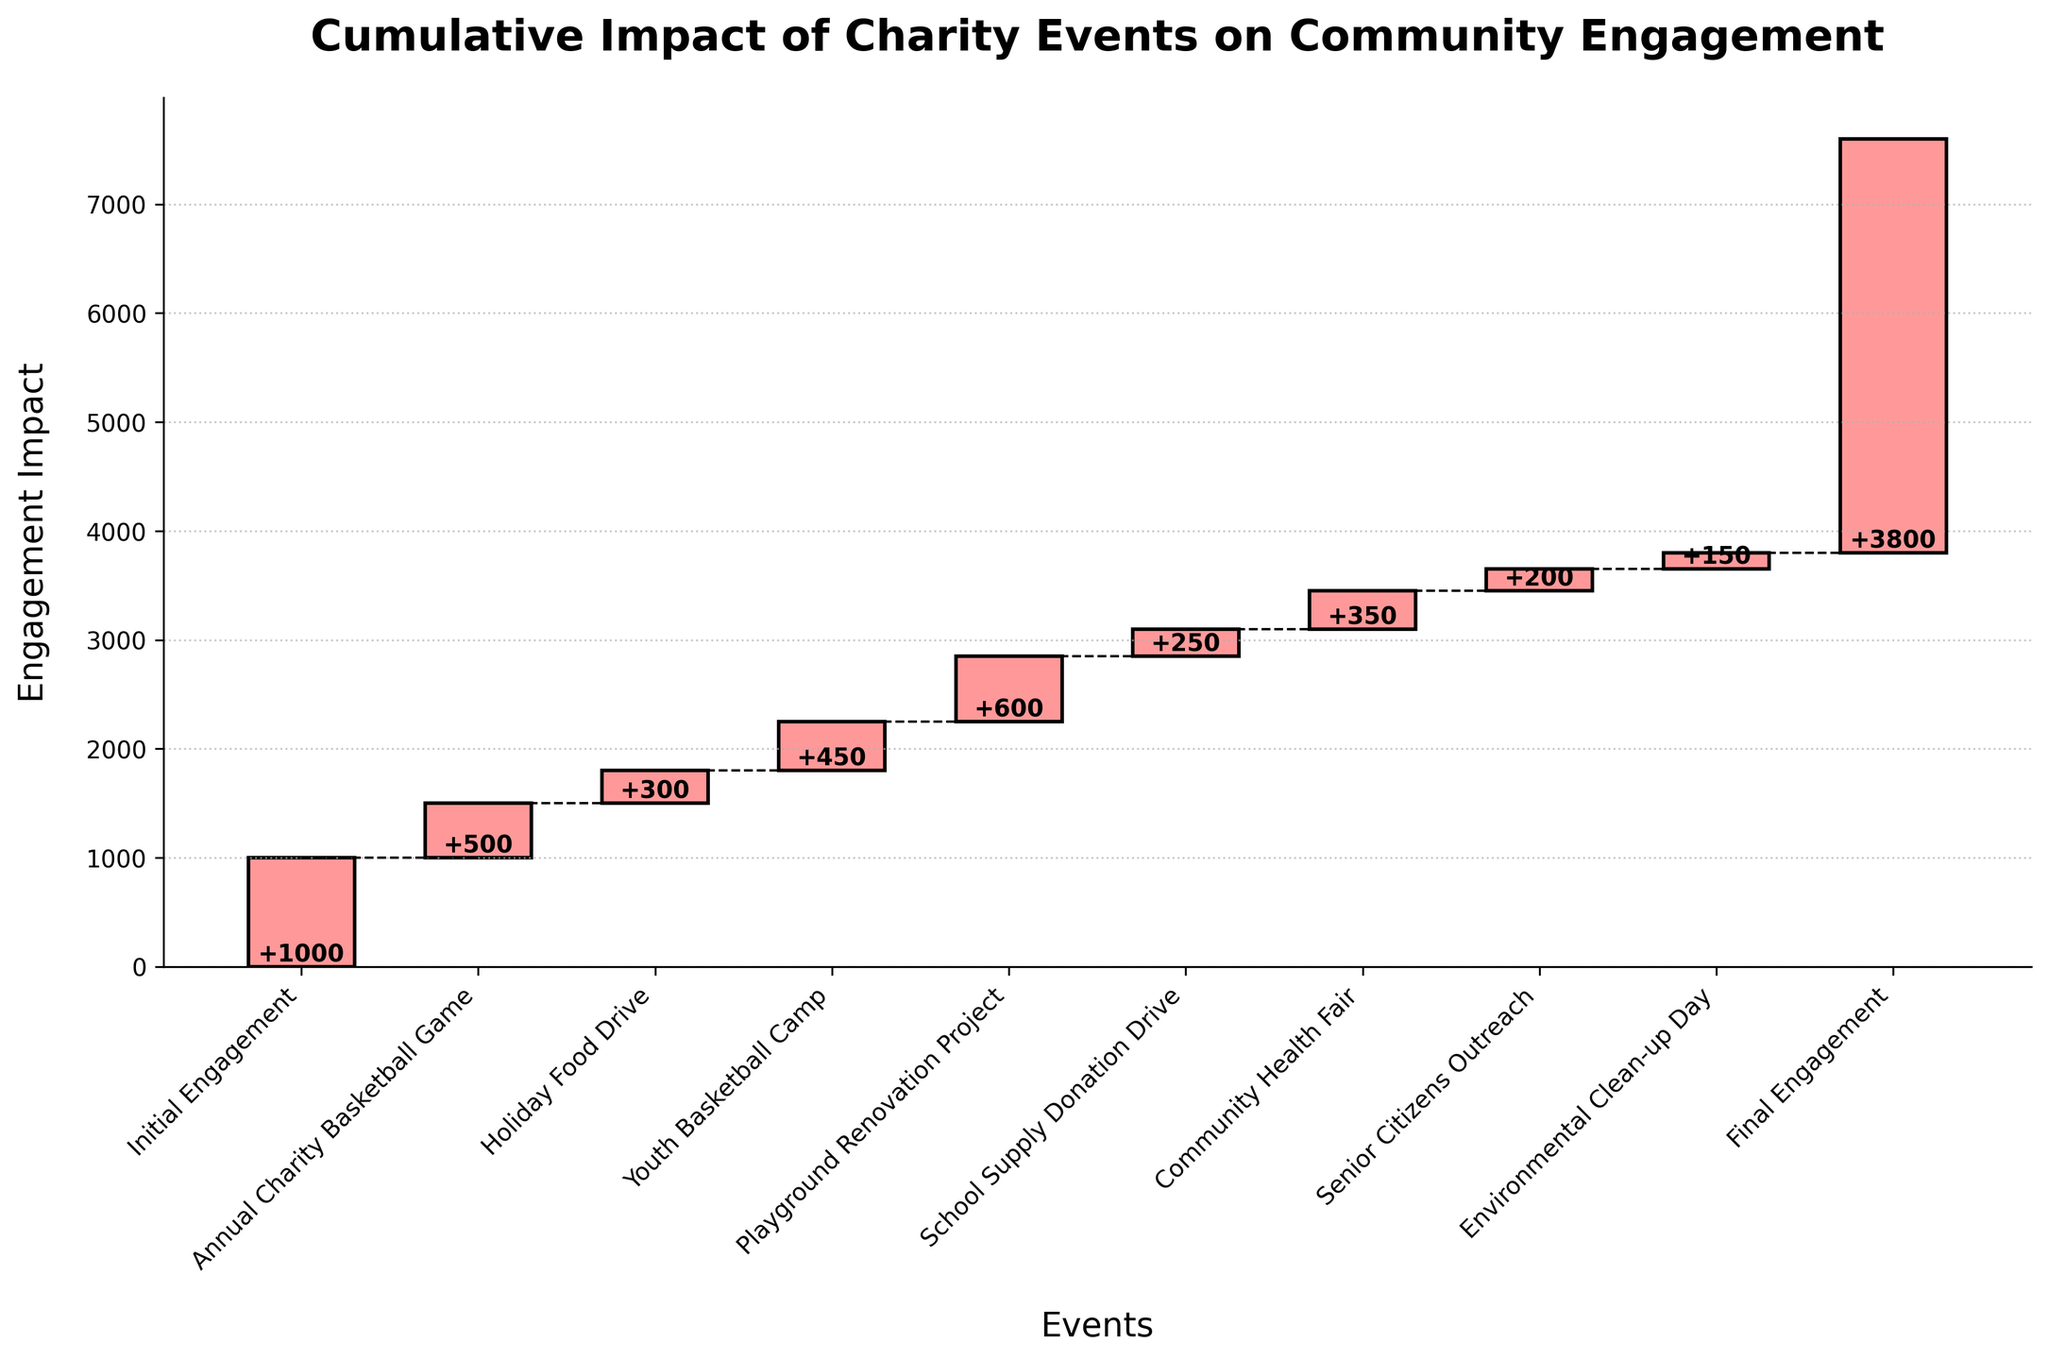What is the title of the chart? The chart's title is prominently displayed at the top of the figure. It reads "Cumulative Impact of Charity Events on Community Engagement".
Answer: Cumulative Impact of Charity Events on Community Engagement Which event had the highest individual impact on community engagement? By looking at the heights of the bars and the labels, the "Playground Renovation Project" had the highest individual impact, adding 600 units to community engagement.
Answer: Playground Renovation Project What is the total engagement impact of all charity events combined? Summing up the positive impacts from each event, we get 500 + 300 + 450 + 600 + 250 + 350 + 200 + 150 = 2800. The final engagement (3800) minus the initial engagement (1000) also confirms this total.
Answer: 2800 How much did the "Senior Citizens Outreach" event contribute to the cumulative engagement? The label on the bar corresponding to "Senior Citizens Outreach" shows it contributed 200 units.
Answer: 200 How does the impact of the "Environmental Clean-up Day" compare to the "School Supply Donation Drive"? The "Environmental Clean-up Day" added 150 units and the "School Supply Donation Drive" added 250 units. Comparing these, the "School Supply Donation Drive" had a greater impact.
Answer: The School Supply Donation Drive had a greater impact What was the cumulative engagement after the "Youth Basketball Camp"? Adding the impacts up to the "Youth Basketball Camp" (+500 +300 +450), the cumulative engagement at that point was 2250.
Answer: 2250 List the charity events in order from the smallest to largest impact. The impacts of the charity events from smallest to largest are: Environmental Clean-up Day (150), Senior Citizens Outreach (200), School Supply Donation Drive (250), Holiday Food Drive (300), Community Health Fair (350), Annual Charity Basketball Game (500), Youth Basketball Camp (450), Playground Renovation Project (600).
Answer: Environmental Clean-up Day, Senior Citizens Outreach, School Supply Donation Drive, Holiday Food Drive, Community Health Fair, Youth Basketball Camp, Annual Charity Basketball Game, Playground Renovation Project What is shown by the dashed lines connecting the bars in the chart? The dashed lines indicate the cumulative engagement level after each event. They show how the engagement changes from one event to another, maintaining a continuous flow.
Answer: Cumulative engagement flow How much was the engagement increase from the start to the end of the "Playground Renovation Project" event? Cumulative engagement before the "Playground Renovation Project" was 2250, and the impact of the event was 600 units. So, the cumulative engagement after this event was 2250 + 600 = 2850. The increase was 600 units.
Answer: 600 units 